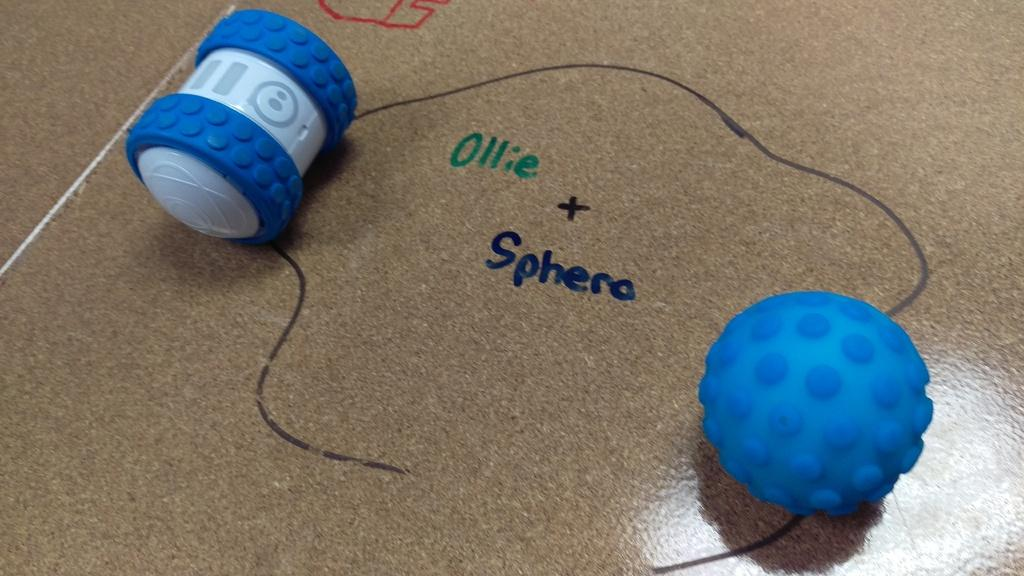<image>
Render a clear and concise summary of the photo. Blue ball next to the words "Ollie + Sphera". 